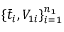Convert formula to latex. <formula><loc_0><loc_0><loc_500><loc_500>\{ \bar { t } _ { i } , V _ { 1 i } \} _ { i = 1 } ^ { n _ { 1 } }</formula> 